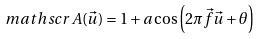Convert formula to latex. <formula><loc_0><loc_0><loc_500><loc_500>\ m a t h s c r { A } ( \vec { u } ) = 1 + a \cos \left ( 2 \pi \vec { f } \vec { u } + \theta \right )</formula> 